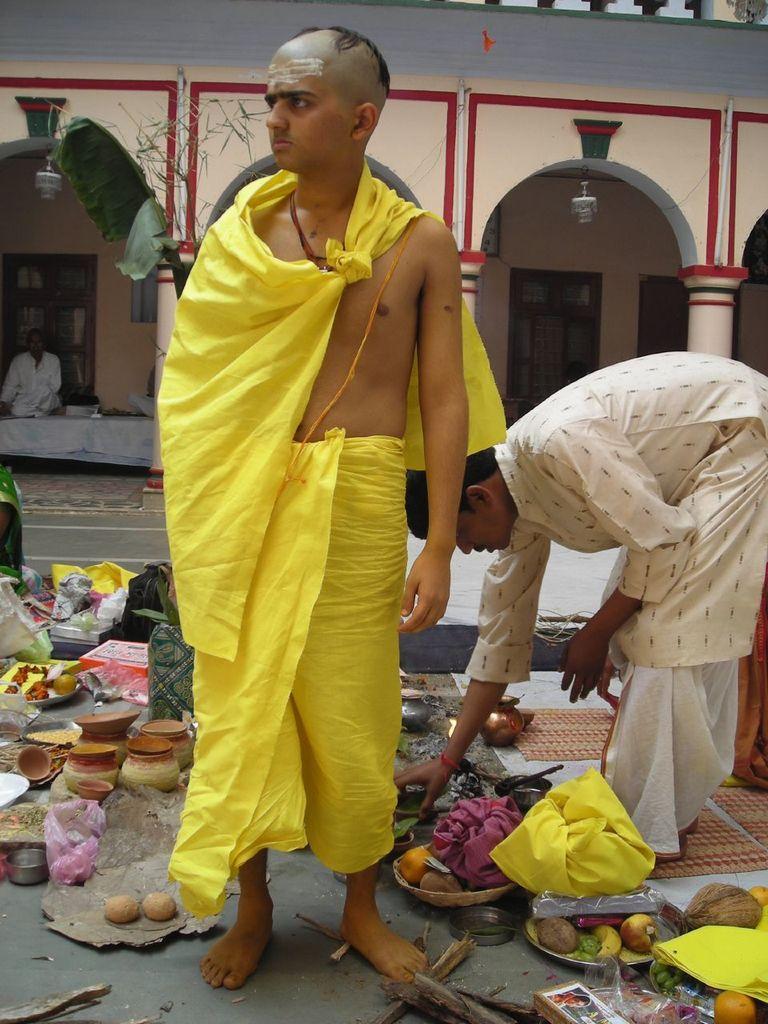Could you give a brief overview of what you see in this image? In the middle of this image there is a man standing and looking at the left side. On the right side there is another man bending and holding an objects. At the bottom I can see few bowls, plates, fruits, clothes, boxes and some other objects on the ground. On the left side there is a person sitting on a table which is covered with a cloth. In the background there is a building. 